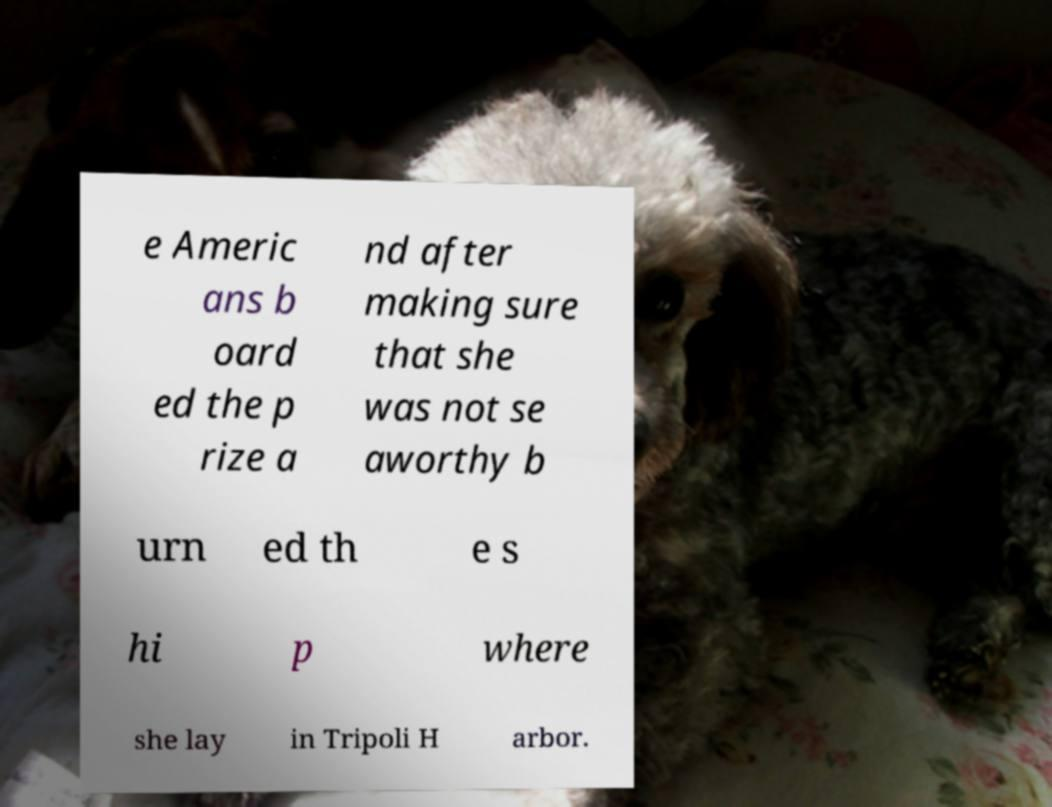Can you accurately transcribe the text from the provided image for me? e Americ ans b oard ed the p rize a nd after making sure that she was not se aworthy b urn ed th e s hi p where she lay in Tripoli H arbor. 